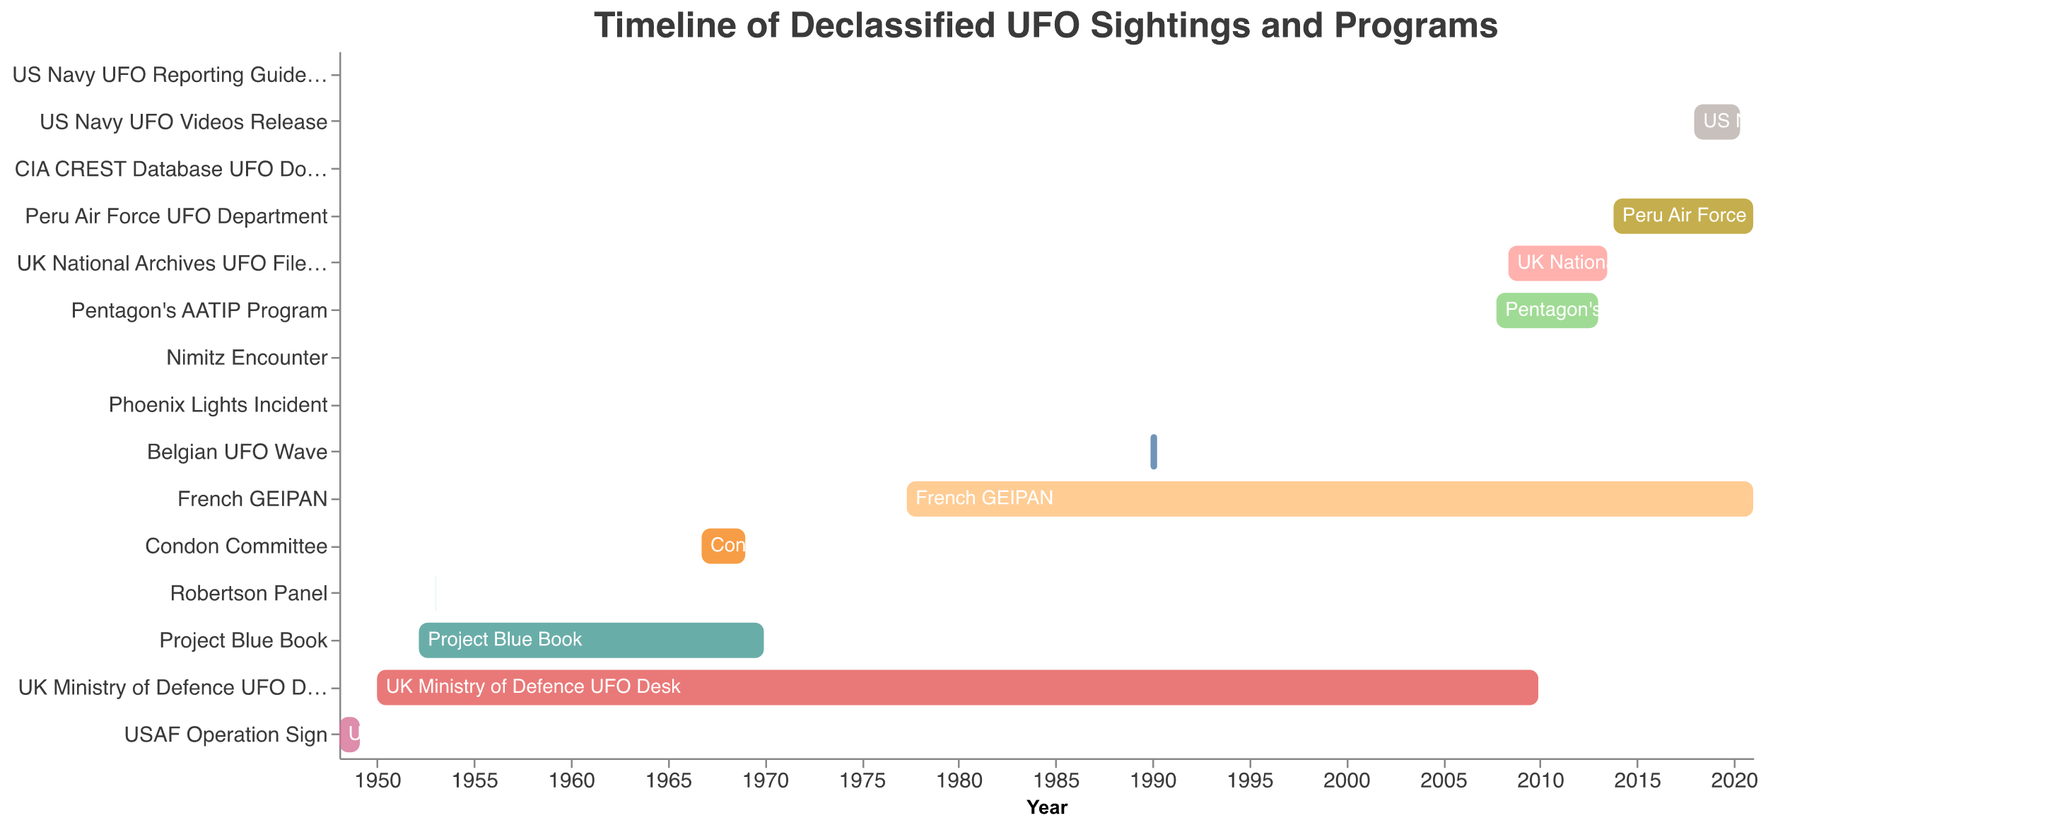What's the title of the Gantt Chart? The title of the chart is usually located at the top of the figure. It describes the overall theme or subject of the chart. Read the title at the top of the chart to find the answer.
Answer: Timeline of Declassified UFO Sightings and Programs What is the timeframe covered in the Gantt Chart? To determine the timeframe, look at the x-axis, which represents the time range from the earliest start date to the latest end date. Identify the earliest and latest dates on the x-axis.
Answer: 1948 to 2020 Which project or event had the earliest starting point? Examine the leftmost bars on the Gantt Chart and identify the one that starts earliest on the x-axis. The task with the earliest start date will be the one closest to the beginning of the timeline.
Answer: USAF Operation Sign What is the duration of Project Blue Book? Find the bar corresponding to "Project Blue Book," and note the start and end dates on the x-axis. Calculate the difference between these dates to get the duration.
Answer: 17 years and 9 months How many projects or events occurred in the 2000s? Identify all bars that have start or end dates within the decade of 2000-2009. Count these bars to determine how many projects or events occurred during this period.
Answer: 5 What is the longest ongoing project or event in the Gantt Chart? Look for the project or event with the longest bar, with the most extended duration on the timeline. Compare the lengths of all bars to find the longest one.
Answer: UK Ministry of Defence UFO Desk Which projects or events only lasted for a single day? Identify the bars whose start and end dates are the same, indicating that the project or event lasted only one day. Make a note of all such bars.
Answer: Phoenix Lights Incident, Nimitz Encounter, CIA CREST Database UFO Documents, US Navy UFO Reporting Guidelines How do the durations of the Robertson Panel and the Condon Committee compare? Examine the bars corresponding to the "Robertson Panel" and "Condon Committee." Note their start and end dates. Calculate their durations and compare to determine which was longer.
Answer: The Condon Committee lasted significantly longer than the Robertson Panel Which two projects or events ran concurrently with the Pentagon's AATIP Program? Identify the timeframe of the Pentagon's AATIP Program by its start and end dates. Look for other bars that overlap with this period and identify them.
Answer: UK National Archives UFO Files Release, Peru Air Force UFO Department 